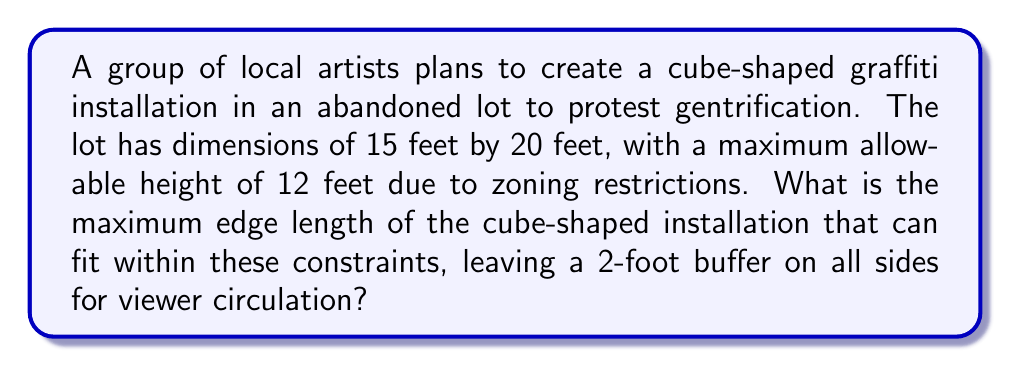Can you solve this math problem? Let's approach this step-by-step:

1) First, we need to determine the maximum available space for the cube in each dimension:

   Width: $15 - 2 - 2 = 11$ feet
   Length: $20 - 2 - 2 = 16$ feet
   Height: $12 - 2 = 10$ feet

2) The cube must fit within all of these dimensions. Since a cube has equal edges, its size will be limited by the smallest of these dimensions.

3) The smallest dimension is the height, at 10 feet.

4) Therefore, the maximum edge length of the cube is 10 feet.

We can verify this:
- The 10-foot cube fits within the 11-foot width
- The 10-foot cube fits within the 16-foot length
- The 10-foot cube exactly fits the 10-foot height

5) We can express the volume of this cube mathematically:

   $$V = s^3 = 10^3 = 1000 \text{ cubic feet}$$

   where $s$ is the length of an edge.

[asy]
import three;

size(200);
currentprojection=perspective(6,3,2);

draw(box((0,0,0),(10,10,10)),blue);
draw(box((0,0,0),(11,16,10)),opacity(0.1));

label("10'",(5,10,0),S);
label("10'",(0,5,0),W);
label("10'",(0,0,5),N);

label("11'",(5.5,16,0),S);
label("16'",(11,8,0),E);

draw((0,0,10)--(0,0,12),dashed);
label("2' buffer",(0,0,11),W);
[/asy]
Answer: The maximum edge length of the cube-shaped installation is 10 feet. 